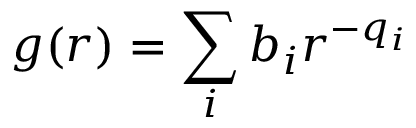Convert formula to latex. <formula><loc_0><loc_0><loc_500><loc_500>g ( r ) = \sum _ { i } b _ { i } r ^ { - q _ { i } }</formula> 